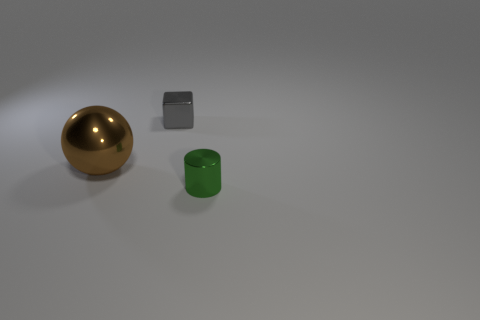Add 3 yellow cylinders. How many objects exist? 6 Subtract all spheres. How many objects are left? 2 Add 3 tiny gray shiny cubes. How many tiny gray shiny cubes are left? 4 Add 1 small blue rubber spheres. How many small blue rubber spheres exist? 1 Subtract 0 cyan spheres. How many objects are left? 3 Subtract all brown things. Subtract all big things. How many objects are left? 1 